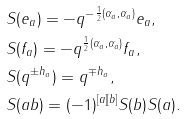<formula> <loc_0><loc_0><loc_500><loc_500>& S ( e _ { a } ) = - q ^ { - \frac { 1 } { 2 } ( \alpha _ { a } , \alpha _ { a } ) } e _ { a } , \\ & S ( f _ { a } ) = - q ^ { \frac { 1 } { 2 } ( \alpha _ { a } , \alpha _ { a } ) } f _ { a } , \\ & S ( q ^ { \pm h _ { a } } ) = q ^ { \mp h _ { a } } , \\ & S ( a b ) = ( - 1 ) ^ { [ a ] [ b ] } S ( b ) S ( a ) .</formula> 